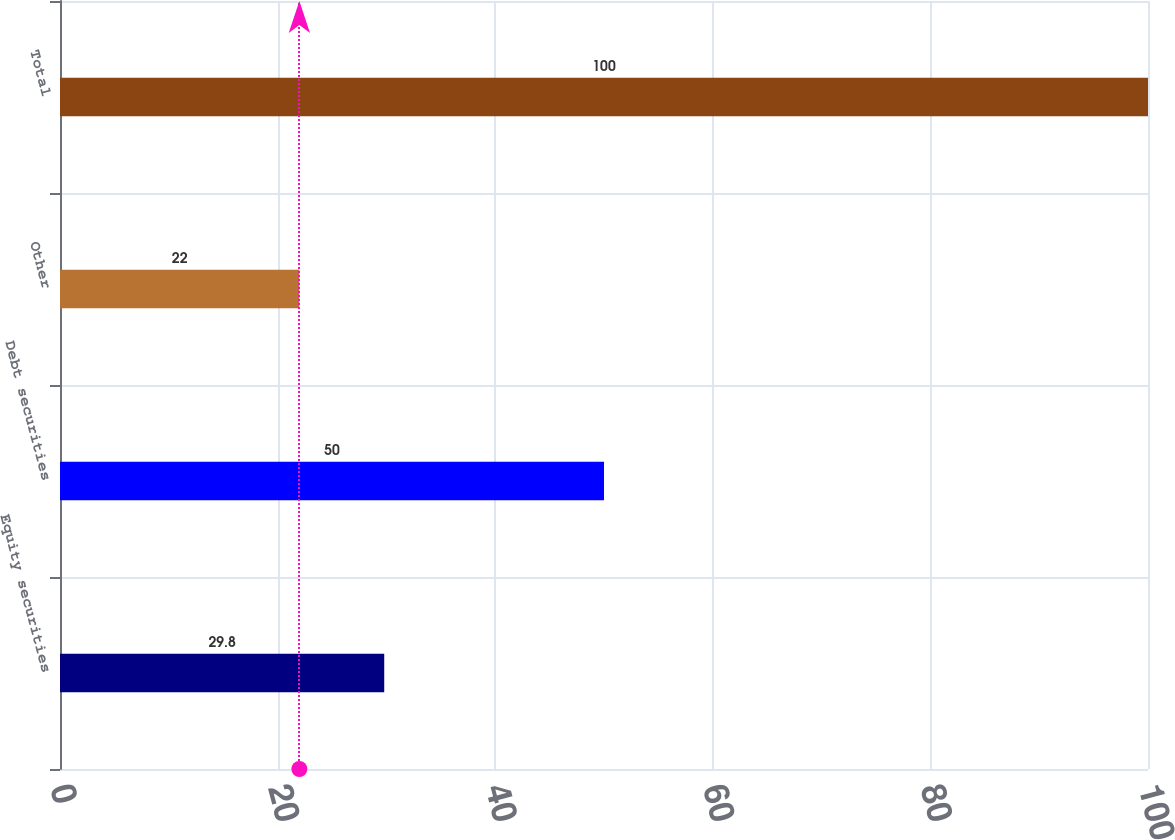<chart> <loc_0><loc_0><loc_500><loc_500><bar_chart><fcel>Equity securities<fcel>Debt securities<fcel>Other<fcel>Total<nl><fcel>29.8<fcel>50<fcel>22<fcel>100<nl></chart> 